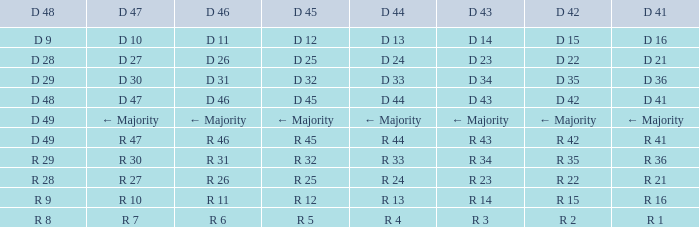Name the D 47 when it has a D 48 of d 49 and D 42 of r 42 R 47. 